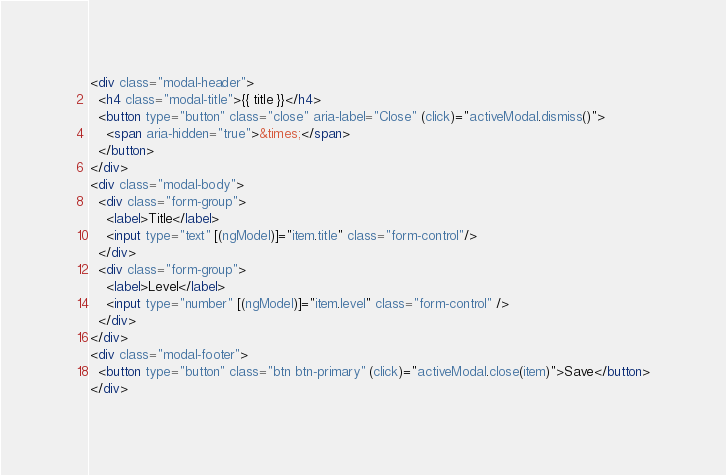<code> <loc_0><loc_0><loc_500><loc_500><_HTML_><div class="modal-header">
  <h4 class="modal-title">{{ title }}</h4>
  <button type="button" class="close" aria-label="Close" (click)="activeModal.dismiss()">
    <span aria-hidden="true">&times;</span>
  </button>
</div>
<div class="modal-body">
  <div class="form-group">
    <label>Title</label>
    <input type="text" [(ngModel)]="item.title" class="form-control"/>
  </div>
  <div class="form-group">
    <label>Level</label>
    <input type="number" [(ngModel)]="item.level" class="form-control" />
  </div>
</div>
<div class="modal-footer">
  <button type="button" class="btn btn-primary" (click)="activeModal.close(item)">Save</button>
</div>
</code> 